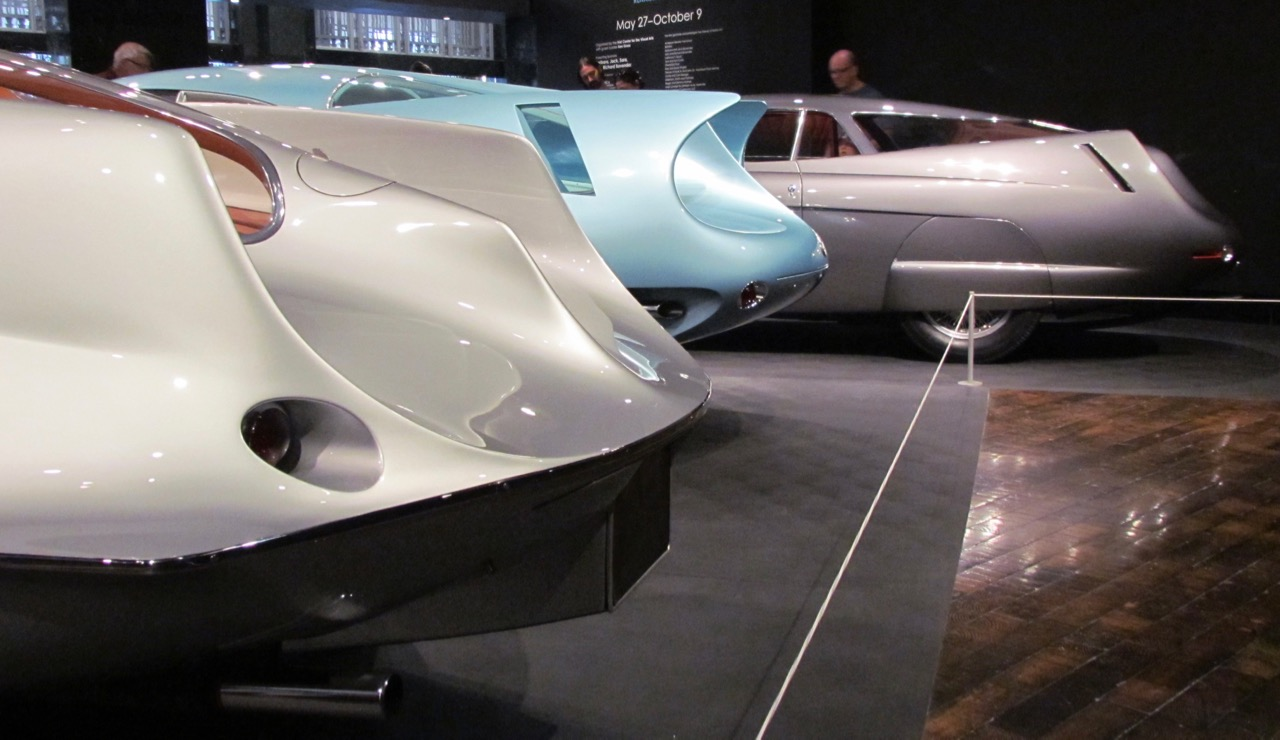How do the design elements visible on these cars impact their aerodynamic performance? The design elements on these cars, such as the teardrop shapes and smooth curves, significantly enhance their aerodynamic performance by reducing air resistance. The streamlined profiles minimize drag, allowing the cars to move more efficiently through the air. Circular side vents not only add to the aesthetic but also aid in cooling systems and further reducing drag by managing the airflow around the vehicle. These features collectively improve the overall speed and fuel efficiency, reflecting the influence of aerodynamic principles derived from aviation technology. That's fascinating! Can you tell me more about how these aerodynamic principles were implemented in other areas of technology during that era? Certainly! During the mid-20th century, aerodynamic principles were widely embraced across various fields, most notably in aviation, naval engineering, and even architecture. In aviation, the focus on streamlining led to the development of faster and more efficient aircraft with smoother fuselages and optimized wing shapes. In naval engineering, similar principles guided the design of sleek, streamlined ships and submarines to reduce water resistance and enhance speed. The architecture of this era saw the adoption of flowing lines and curved surfaces, epitomized by the Art Deco movement, which emphasized sleekness and modernity. Streamlined design became a symbol of progress and innovation, celebrated not just for its functional benefits but also for its futuristic aesthetic. 